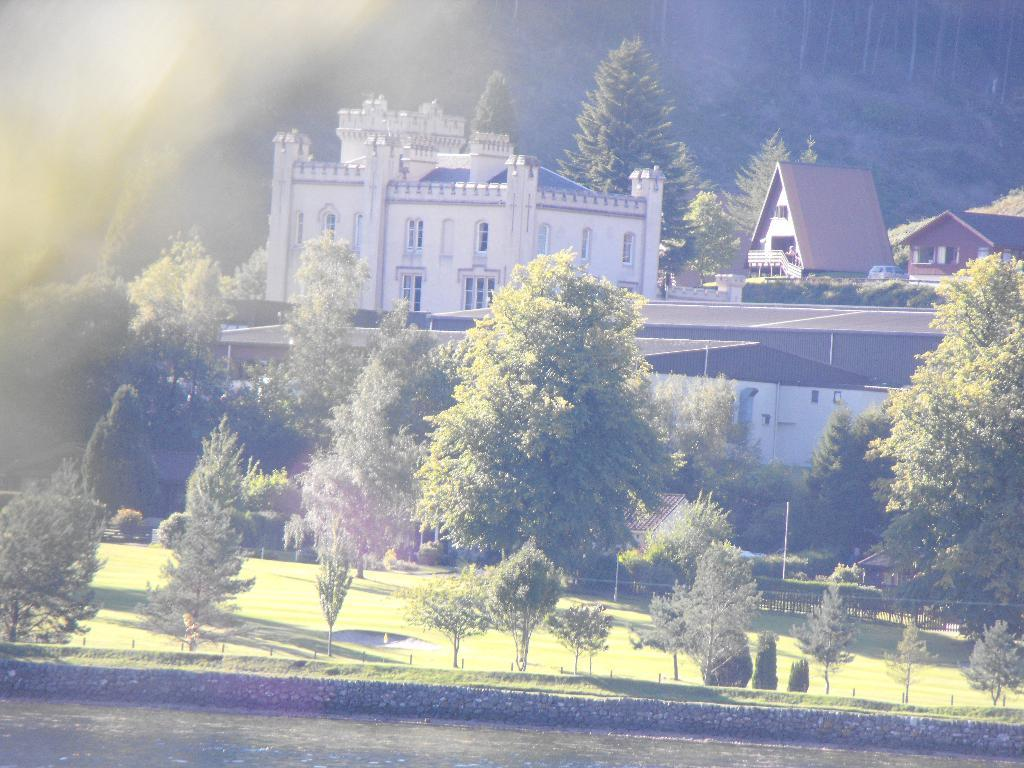What type of building is depicted in the image? There is a building in the image that resembles a castle. What is the surrounding environment of the building? The building is surrounded by trees, plants, and houses. What type of celery can be seen growing near the jail in the image? There is no jail or celery present in the image. 